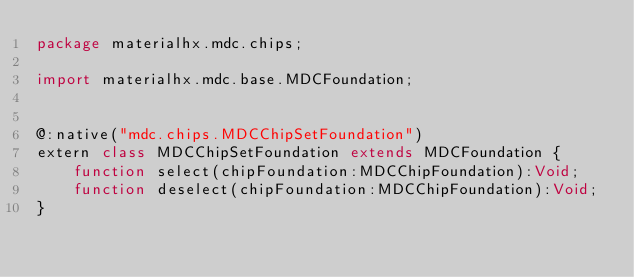Convert code to text. <code><loc_0><loc_0><loc_500><loc_500><_Haxe_>package materialhx.mdc.chips;

import materialhx.mdc.base.MDCFoundation;


@:native("mdc.chips.MDCChipSetFoundation")
extern class MDCChipSetFoundation extends MDCFoundation {
    function select(chipFoundation:MDCChipFoundation):Void;
    function deselect(chipFoundation:MDCChipFoundation):Void;
}
</code> 